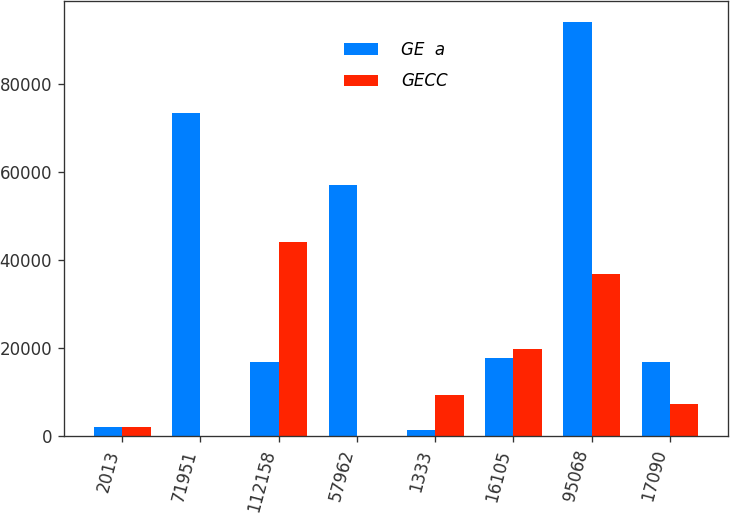Convert chart to OTSL. <chart><loc_0><loc_0><loc_500><loc_500><stacked_bar_chart><ecel><fcel>2013<fcel>71951<fcel>112158<fcel>57962<fcel>1333<fcel>16105<fcel>95068<fcel>17090<nl><fcel>GE  a<fcel>2012<fcel>73304<fcel>16797<fcel>57118<fcel>1353<fcel>17671<fcel>94080<fcel>16797<nl><fcel>GECC<fcel>2013<fcel>126<fcel>44067<fcel>108<fcel>9267<fcel>19776<fcel>36748<fcel>7319<nl></chart> 